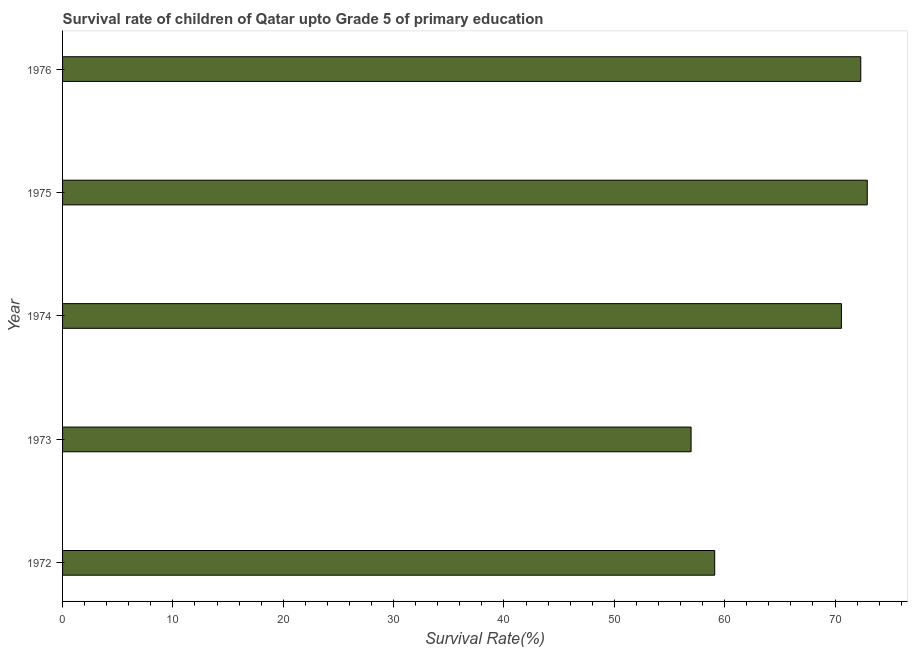Does the graph contain any zero values?
Your response must be concise. No. What is the title of the graph?
Give a very brief answer. Survival rate of children of Qatar upto Grade 5 of primary education. What is the label or title of the X-axis?
Offer a very short reply. Survival Rate(%). What is the label or title of the Y-axis?
Provide a succinct answer. Year. What is the survival rate in 1972?
Give a very brief answer. 59.09. Across all years, what is the maximum survival rate?
Your answer should be very brief. 72.92. Across all years, what is the minimum survival rate?
Offer a very short reply. 56.96. In which year was the survival rate maximum?
Ensure brevity in your answer.  1975. In which year was the survival rate minimum?
Give a very brief answer. 1973. What is the sum of the survival rate?
Your response must be concise. 331.88. What is the difference between the survival rate in 1972 and 1974?
Offer a terse response. -11.48. What is the average survival rate per year?
Offer a very short reply. 66.38. What is the median survival rate?
Your answer should be compact. 70.58. In how many years, is the survival rate greater than 30 %?
Your response must be concise. 5. What is the ratio of the survival rate in 1974 to that in 1975?
Give a very brief answer. 0.97. Is the survival rate in 1973 less than that in 1974?
Give a very brief answer. Yes. Is the difference between the survival rate in 1972 and 1973 greater than the difference between any two years?
Give a very brief answer. No. What is the difference between the highest and the second highest survival rate?
Your response must be concise. 0.59. Is the sum of the survival rate in 1973 and 1974 greater than the maximum survival rate across all years?
Your response must be concise. Yes. What is the difference between the highest and the lowest survival rate?
Provide a short and direct response. 15.96. How many bars are there?
Give a very brief answer. 5. How many years are there in the graph?
Your answer should be compact. 5. What is the difference between two consecutive major ticks on the X-axis?
Give a very brief answer. 10. What is the Survival Rate(%) in 1972?
Offer a terse response. 59.09. What is the Survival Rate(%) in 1973?
Provide a short and direct response. 56.96. What is the Survival Rate(%) of 1974?
Provide a succinct answer. 70.58. What is the Survival Rate(%) in 1975?
Provide a short and direct response. 72.92. What is the Survival Rate(%) in 1976?
Offer a very short reply. 72.33. What is the difference between the Survival Rate(%) in 1972 and 1973?
Your answer should be very brief. 2.14. What is the difference between the Survival Rate(%) in 1972 and 1974?
Your answer should be compact. -11.48. What is the difference between the Survival Rate(%) in 1972 and 1975?
Give a very brief answer. -13.82. What is the difference between the Survival Rate(%) in 1972 and 1976?
Provide a short and direct response. -13.24. What is the difference between the Survival Rate(%) in 1973 and 1974?
Give a very brief answer. -13.62. What is the difference between the Survival Rate(%) in 1973 and 1975?
Offer a very short reply. -15.96. What is the difference between the Survival Rate(%) in 1973 and 1976?
Provide a short and direct response. -15.38. What is the difference between the Survival Rate(%) in 1974 and 1975?
Offer a terse response. -2.34. What is the difference between the Survival Rate(%) in 1974 and 1976?
Your answer should be very brief. -1.75. What is the difference between the Survival Rate(%) in 1975 and 1976?
Your answer should be very brief. 0.59. What is the ratio of the Survival Rate(%) in 1972 to that in 1973?
Offer a terse response. 1.04. What is the ratio of the Survival Rate(%) in 1972 to that in 1974?
Provide a succinct answer. 0.84. What is the ratio of the Survival Rate(%) in 1972 to that in 1975?
Provide a succinct answer. 0.81. What is the ratio of the Survival Rate(%) in 1972 to that in 1976?
Your answer should be very brief. 0.82. What is the ratio of the Survival Rate(%) in 1973 to that in 1974?
Offer a terse response. 0.81. What is the ratio of the Survival Rate(%) in 1973 to that in 1975?
Your answer should be very brief. 0.78. What is the ratio of the Survival Rate(%) in 1973 to that in 1976?
Make the answer very short. 0.79. What is the ratio of the Survival Rate(%) in 1974 to that in 1975?
Provide a short and direct response. 0.97. What is the ratio of the Survival Rate(%) in 1974 to that in 1976?
Make the answer very short. 0.98. What is the ratio of the Survival Rate(%) in 1975 to that in 1976?
Provide a short and direct response. 1.01. 